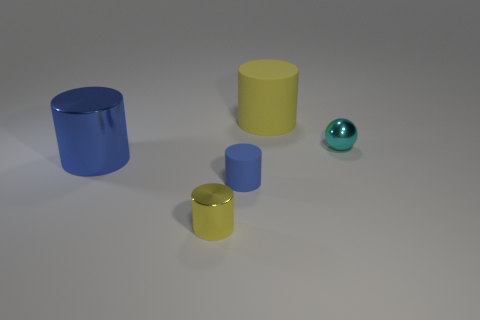What color is the small shiny object behind the big cylinder in front of the metal object behind the blue metallic object?
Your answer should be very brief. Cyan. What material is the other large thing that is the same shape as the large metallic object?
Offer a terse response. Rubber. What number of other yellow matte objects have the same size as the yellow rubber object?
Ensure brevity in your answer.  0. What number of green blocks are there?
Your answer should be very brief. 0. Does the large blue cylinder have the same material as the yellow cylinder behind the blue rubber cylinder?
Your response must be concise. No. What number of cyan things are small cylinders or rubber things?
Offer a terse response. 0. There is a blue cylinder that is made of the same material as the large yellow thing; what is its size?
Keep it short and to the point. Small. What number of other metal things are the same shape as the large yellow object?
Provide a short and direct response. 2. Is the number of large metal objects behind the large yellow matte object greater than the number of blue objects that are behind the cyan object?
Keep it short and to the point. No. There is a small metallic cylinder; is its color the same as the metal thing that is right of the tiny rubber thing?
Offer a very short reply. No. 